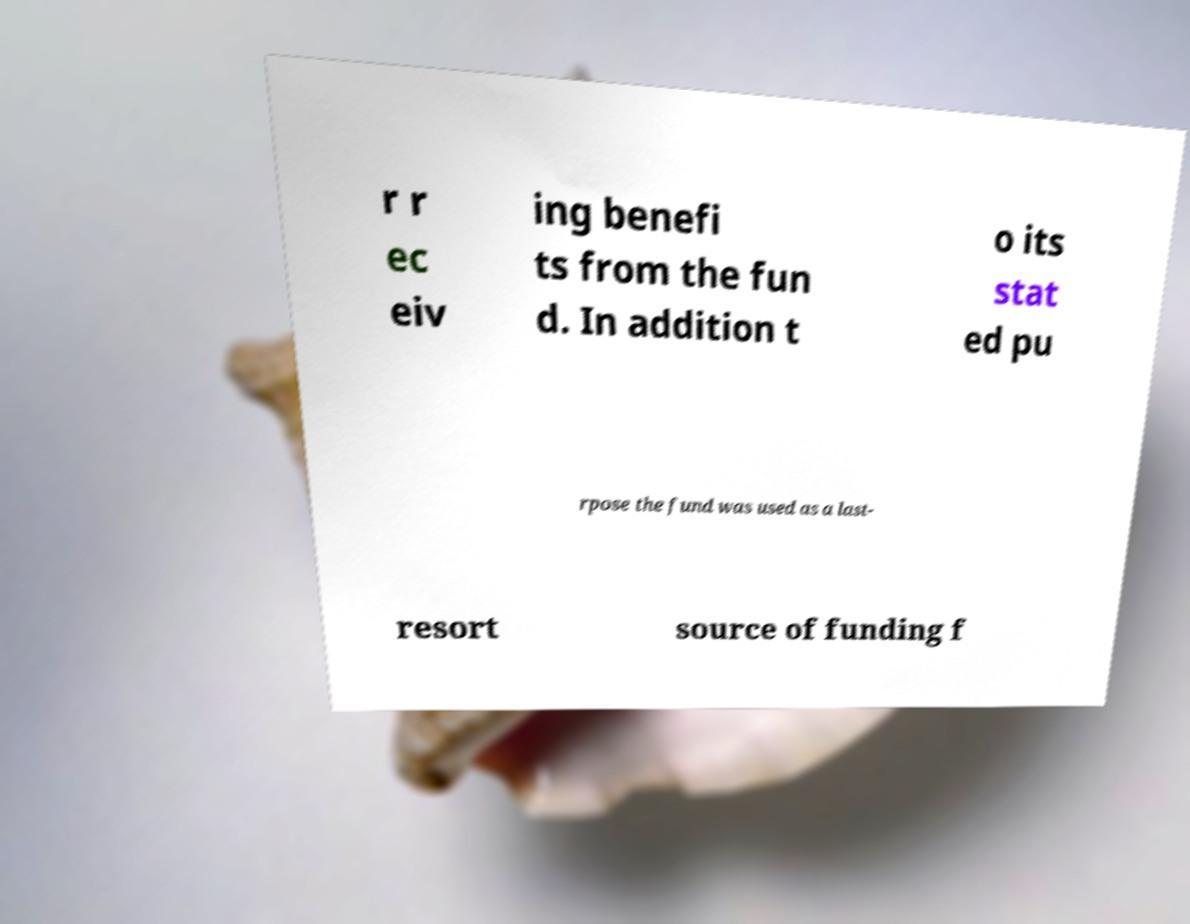I need the written content from this picture converted into text. Can you do that? r r ec eiv ing benefi ts from the fun d. In addition t o its stat ed pu rpose the fund was used as a last- resort source of funding f 